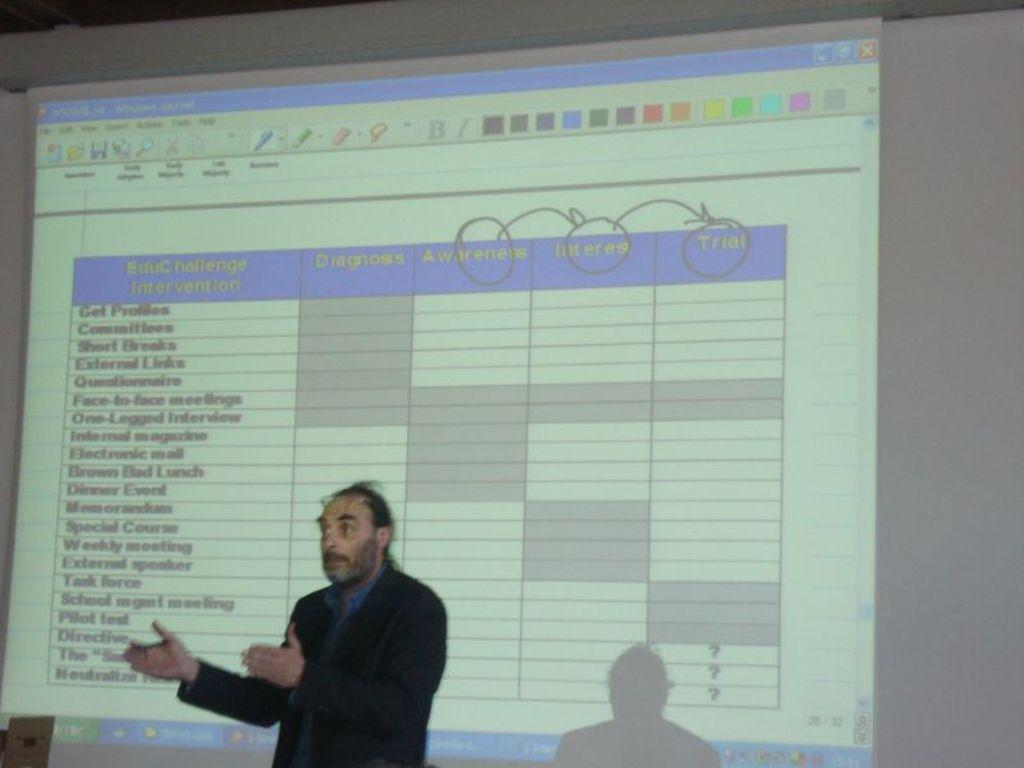What is the main subject of the image? There is a person in the image. What can be seen in the background of the image? There is a screen with some text in the background of the image. What type of wine is being served to the person in the image? There is no wine present in the image. How many hands does the person in the image have? The person in the image has two hands, as humans typically have two hands. 